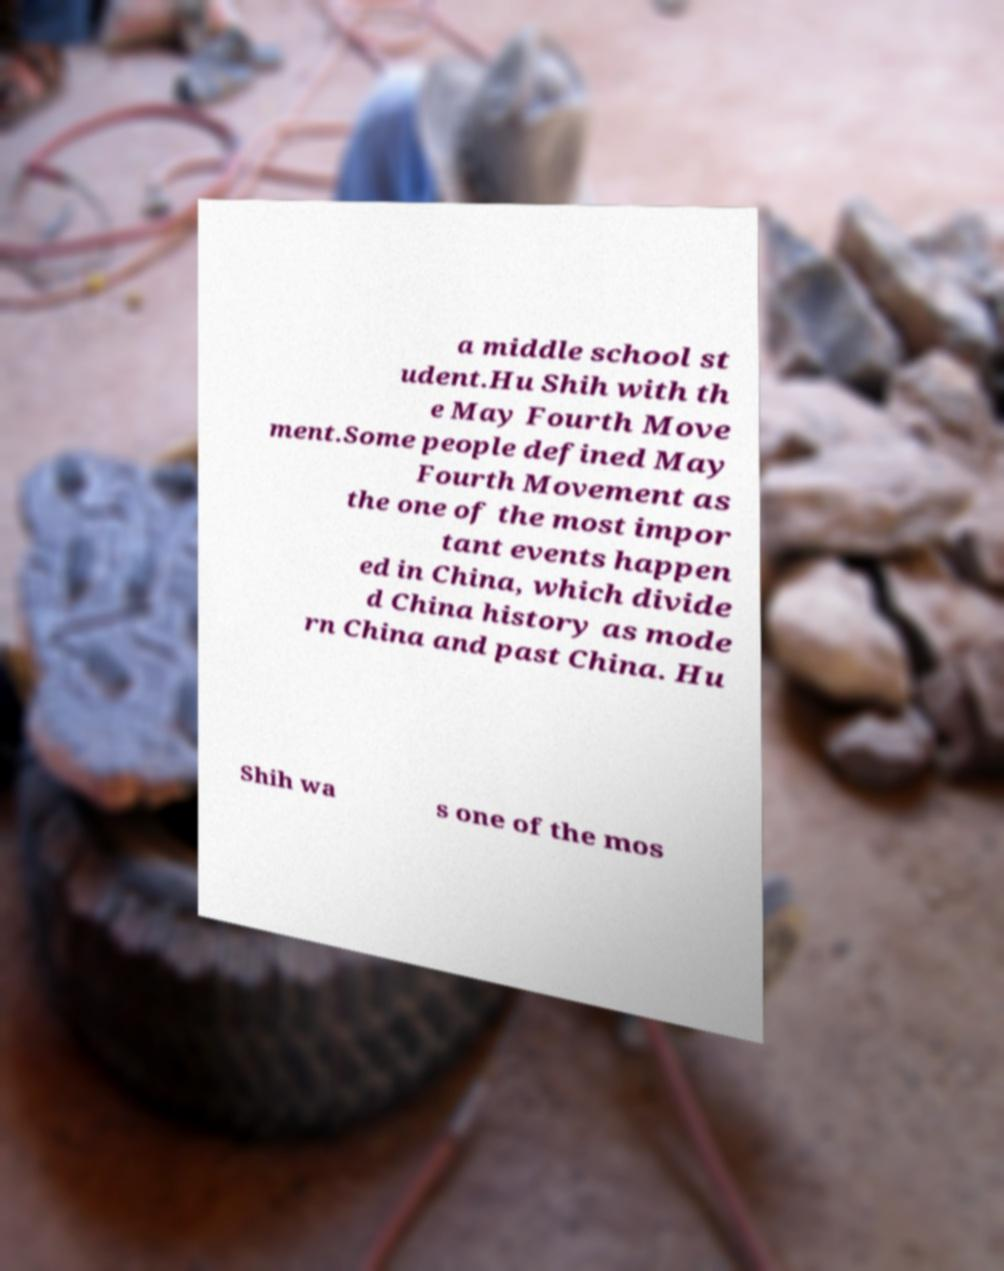Could you assist in decoding the text presented in this image and type it out clearly? a middle school st udent.Hu Shih with th e May Fourth Move ment.Some people defined May Fourth Movement as the one of the most impor tant events happen ed in China, which divide d China history as mode rn China and past China. Hu Shih wa s one of the mos 